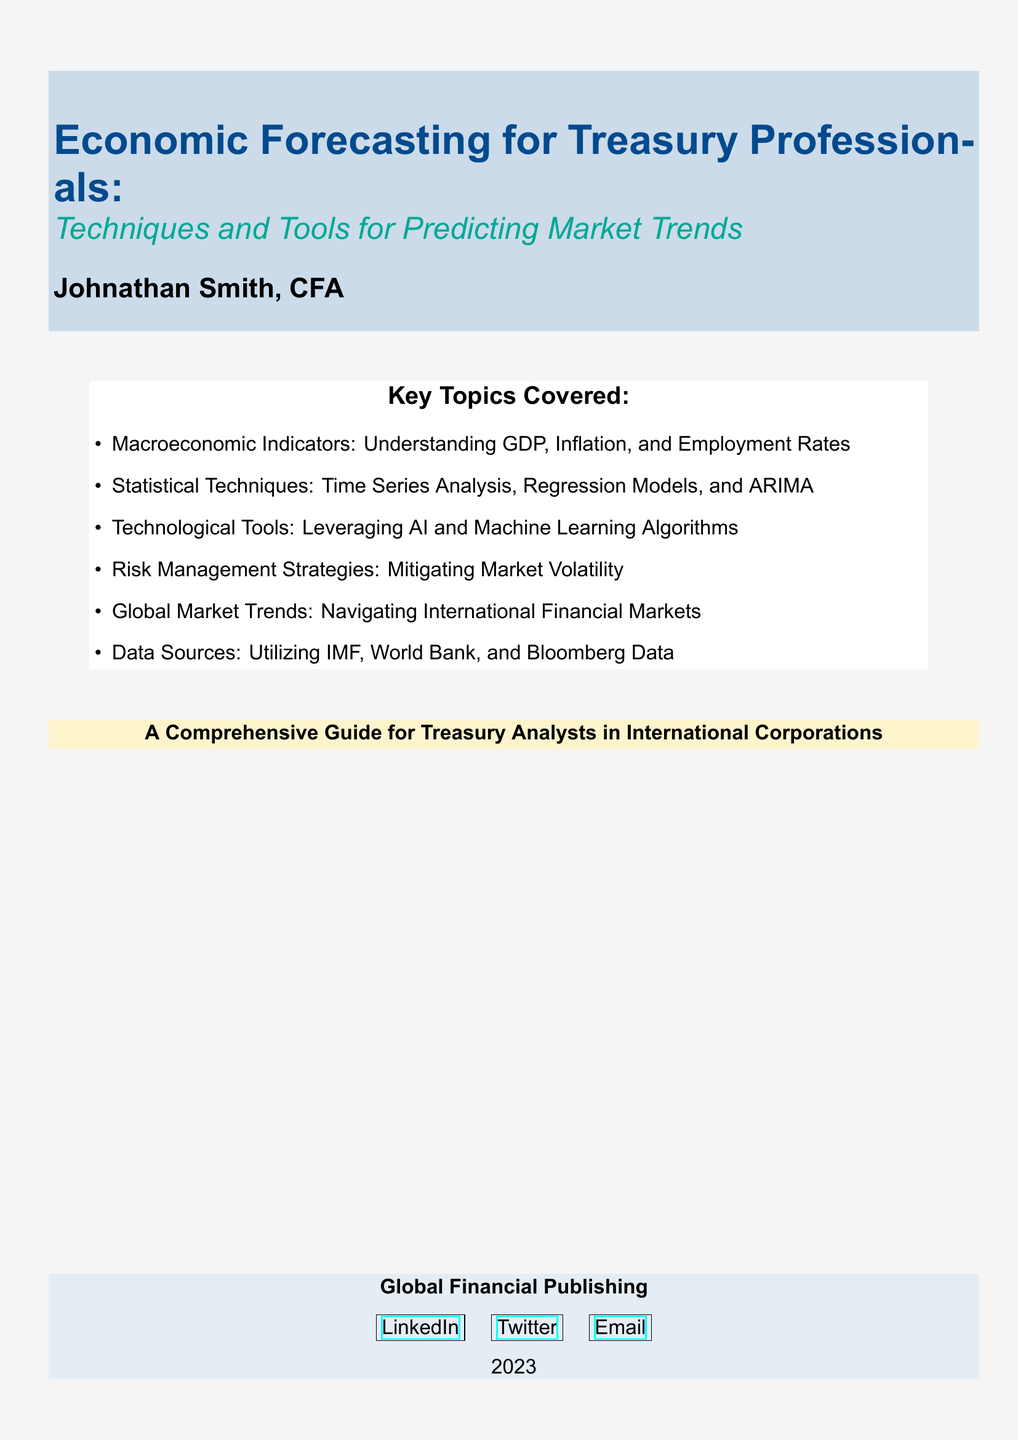What is the main title of the book? The main title is prominently displayed at the top of the document.
Answer: Economic Forecasting for Treasury Professionals Who is the author of the book? The author's name is included below the title section.
Answer: Johnathan Smith, CFA What year was the book published? The publication year is mentioned at the bottom of the document.
Answer: 2023 What is one of the key topics covered in the book? Key topics are listed under the "Key Topics Covered" section.
Answer: Macroeconomic Indicators Which statistical technique is discussed in the book? Statistical techniques are specifically mentioned as part of the key topics.
Answer: Regression Models What type of professionals is this book aimed at? The target audience is stated in the subtitle of the document.
Answer: Treasury Analysts in International Corporations What color is the background of the document? The background color is specified to create a visual theme for the document.
Answer: Gray Which organization’s data is emphasized for use in the book? Data sources are highlighted as crucial for analysis in the book.
Answer: IMF, World Bank, and Bloomberg Data 